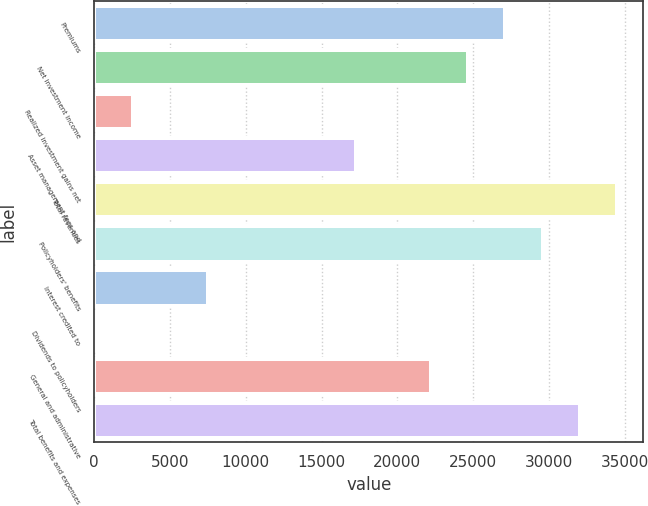<chart> <loc_0><loc_0><loc_500><loc_500><bar_chart><fcel>Premiums<fcel>Net investment income<fcel>Realized investment gains net<fcel>Asset management fees and<fcel>Total revenues<fcel>Policyholders' benefits<fcel>Interest credited to<fcel>Dividends to policyholders<fcel>General and administrative<fcel>Total benefits and expenses<nl><fcel>27133.2<fcel>24676<fcel>2561.2<fcel>17304.4<fcel>34504.8<fcel>29590.4<fcel>7475.6<fcel>104<fcel>22218.8<fcel>32047.6<nl></chart> 